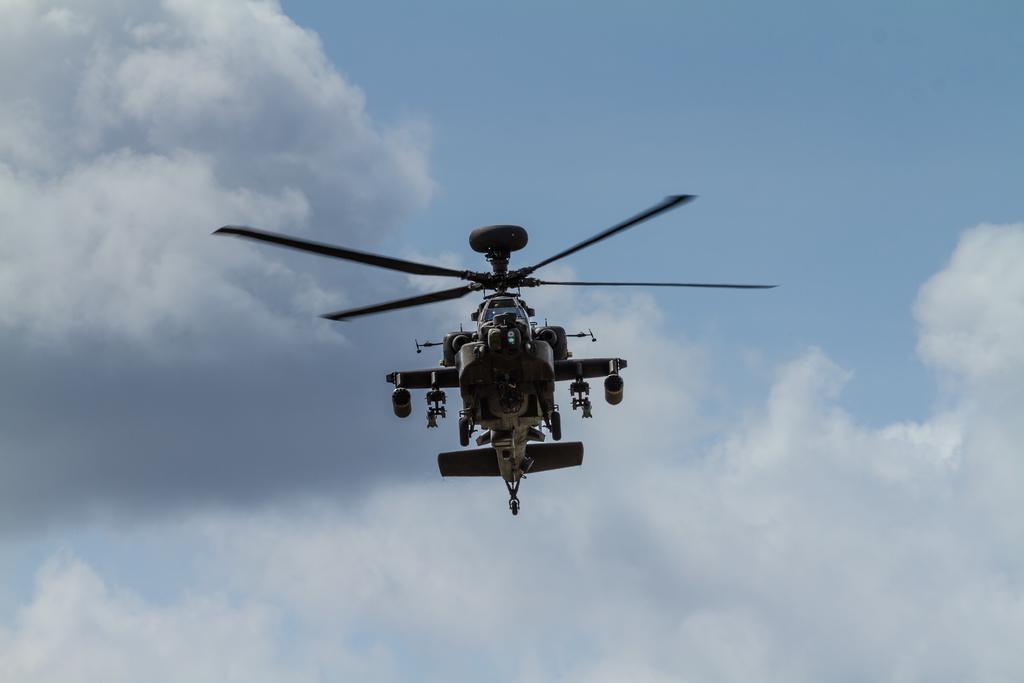Could you give a brief overview of what you see in this image? In the center of the image a helicopter is present. In the background of the image we can see clouds are present in the sky. 